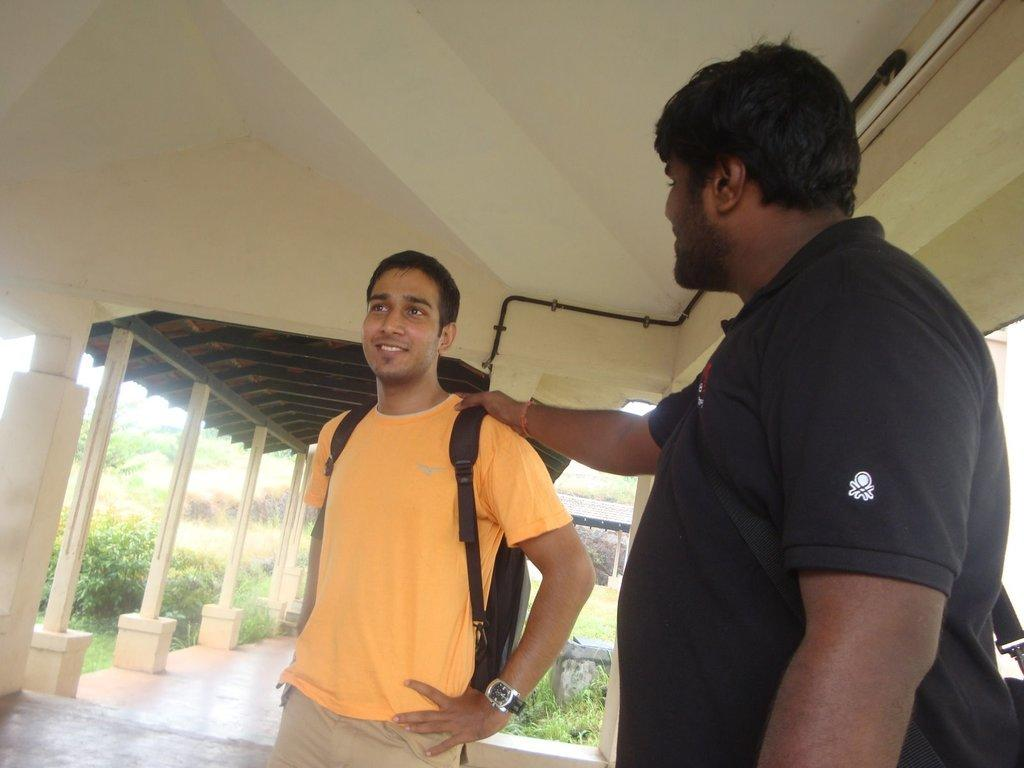How many people are in the image? There are two men standing in the image. Can you describe what one of the men is carrying? One person is wearing a backpack. What can be seen in the background of the image? There is a pole, a shed, plants, grass, and a rod attached to the wall in the background of the image. What type of jeans is the man wearing in the image? There is no information about the man's jeans in the image, so it cannot be determined. 